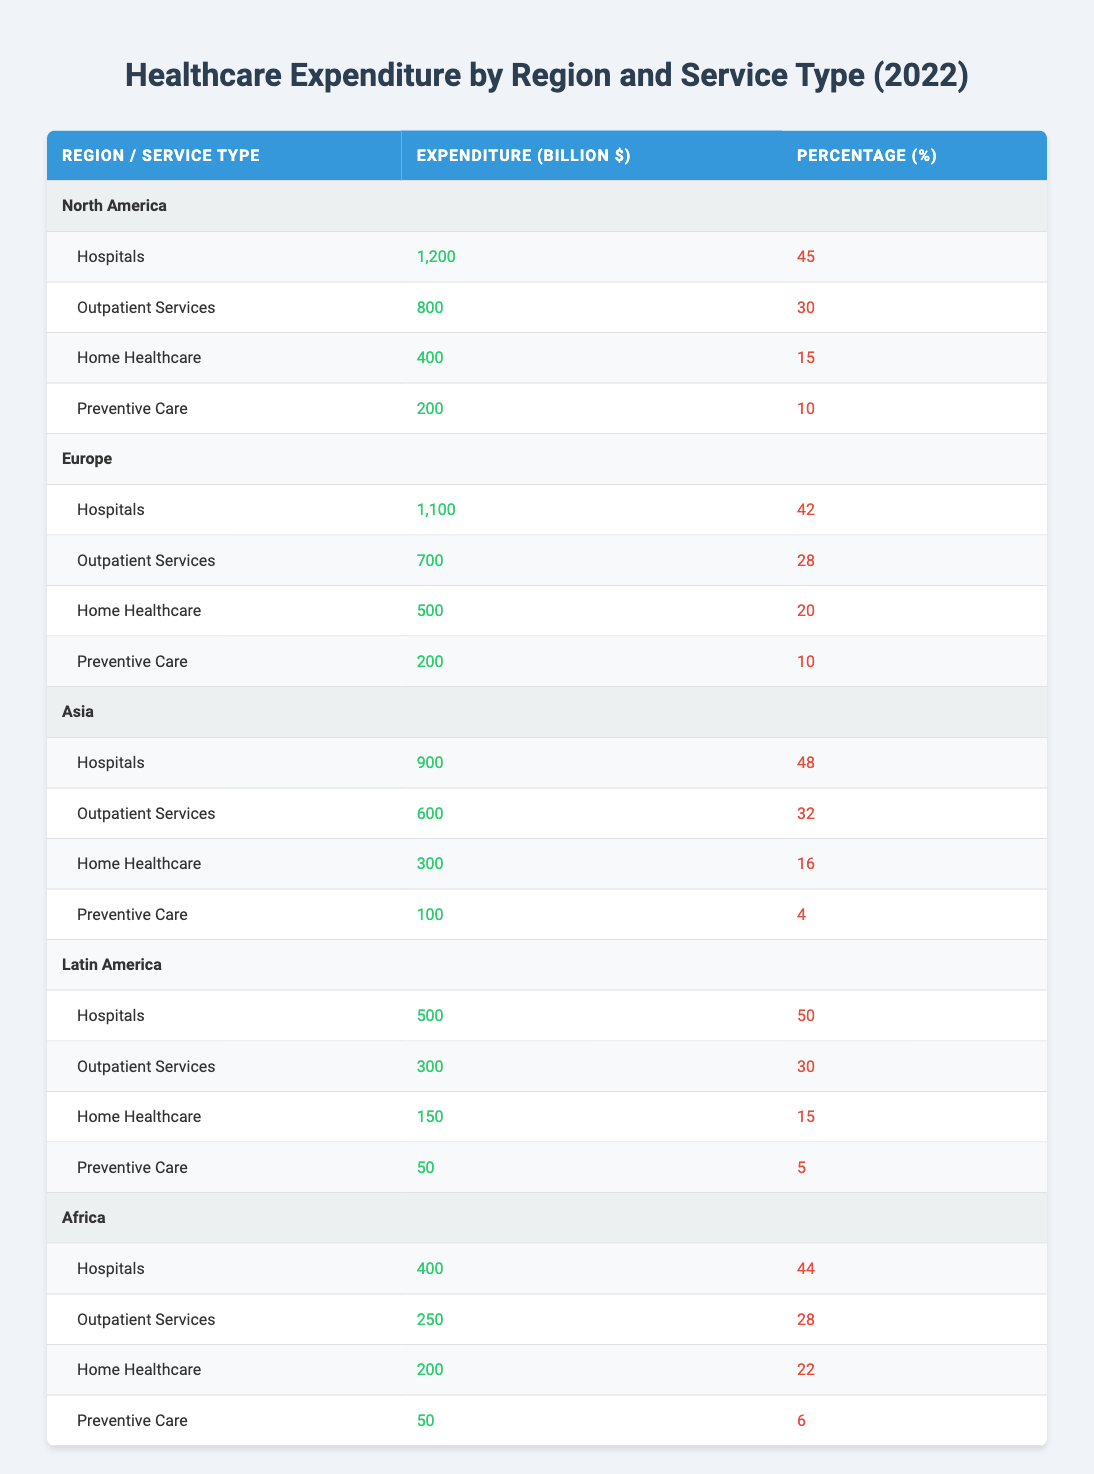What is the total expenditure on Home Healthcare in Europe? From the table, the expenditure on Home Healthcare in Europe is listed as 500 billion dollars.
Answer: 500 billion dollars Which region spent the most on Hospitals in 2022? By comparing the expenditure on Hospitals across different regions in the table, North America spent 1200 billion dollars, which is higher than Europe's 1100 billion dollars, Asia's 900 billion dollars, Latin America's 500 billion dollars, and Africa's 400 billion dollars.
Answer: North America Is the percentage of expenditure on Preventive Care in Asia higher than that in North America? The percentage for Preventive Care in Asia is 4%, while in North America it is 10%. Since 4% is less than 10%, the statement is false.
Answer: No What is the combined expenditure on Outpatient Services and Home Healthcare in Latin America? The expenditure on Outpatient Services in Latin America is 300 billion dollars and on Home Healthcare is 150 billion dollars. Adding those gives 300 + 150 = 450 billion dollars.
Answer: 450 billion dollars Which service type in Africa has the highest percentage of expenditure? In Africa, the service with the highest percentage of expenditure is Home Healthcare at 22%, compared to Hospitals at 44%, Outpatient Services at 28%, and Preventive Care at 6%.
Answer: Home Healthcare 